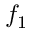<formula> <loc_0><loc_0><loc_500><loc_500>f _ { 1 }</formula> 